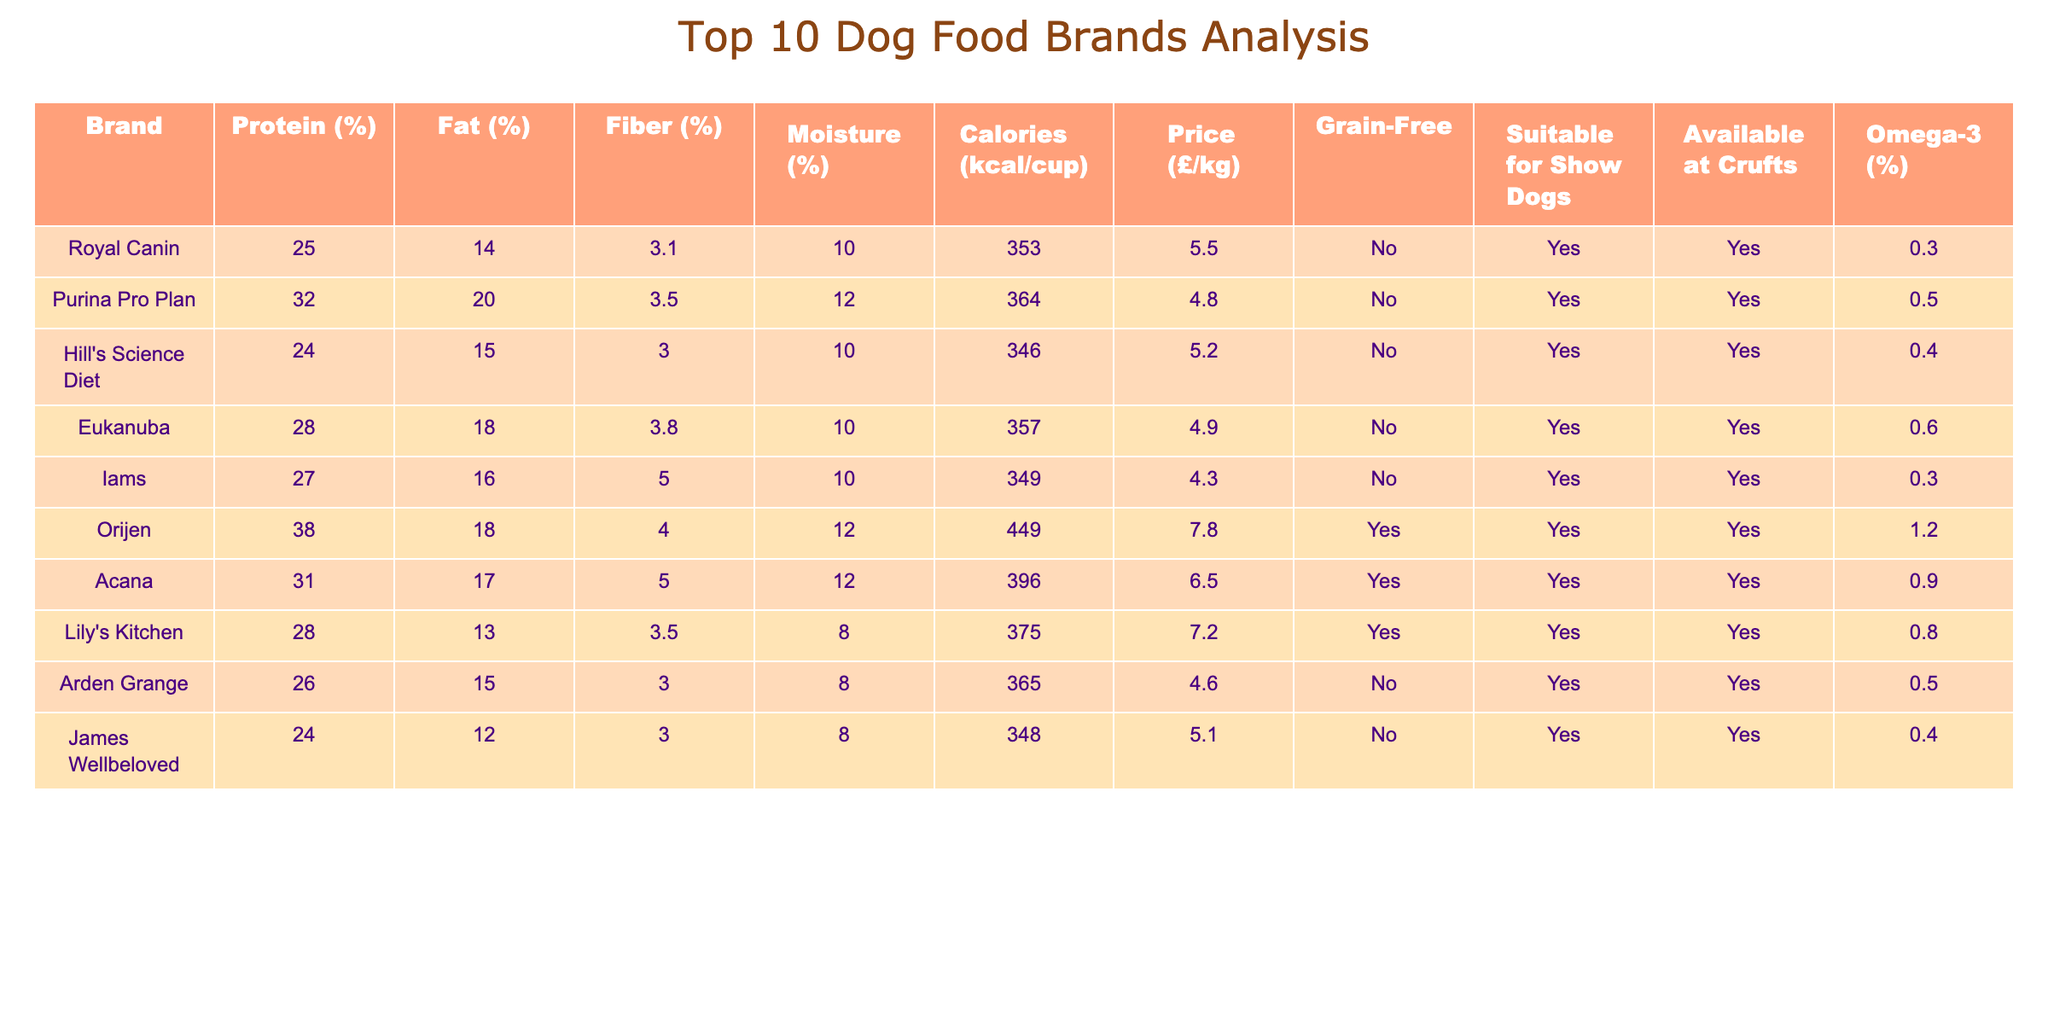What is the highest protein content among the top 10 brands? By looking at the Protein (%) column, the highest value is 38%, which belongs to Orijen.
Answer: 38% Which dog food brand has the lowest price per kg? The Price (£/kg) column shows that Iams has the lowest price at £4.30/kg.
Answer: £4.30/kg How many brands are suitable for show dogs? The "Suitable for Show Dogs" column indicates that all brands except Royal Canin and Iams are suitable, totaling 8 brands.
Answer: 8 What is the average fat percentage of the top 10 dog food brands? Adding the Fat percentages (14 + 20 + 15 + 18 + 16 + 18 + 17 + 13 + 15 + 12 =  18.3) and dividing by 10 gives an average of 18.3%.
Answer: 18.3% Which brand has the highest calorie content per cup? Referring to the Calories (kcal/cup) column, Orijen has the highest calorie content at 449 kcal/cup.
Answer: 449 kcal/cup How many brands are grain-free? Looking at the "Grain-Free" column, we can see that Orijen and Acana are marked as Yes, indicating there are 2 grain-free brands.
Answer: 2 What percentage of the brands available at Crufts are omega-3 enriched? Seven brands have omega-3 content, and since all ten brands are available at Crufts, the percentage is (7/10) * 100 = 70%.
Answer: 70% Are there any brands with fiber content higher than 4%? Scanning through the Fiber (%) column, Orijen (4.0) and Iams (5.0) have values above 4%, confirming 2 brands meet the condition.
Answer: 2 What is the difference in price per kg between the most expensive and the least expensive brand? The most expensive brand is Orijen at £7.80/kg, and the least expensive is Iams at £4.30/kg. The difference is £7.80 - £4.30 = £3.50.
Answer: £3.50 Which brand has the most omega-3 content? Referring to the Omega-3 (%) column, Orijen has the highest omega-3 content at 1.2%.
Answer: 1.2% 